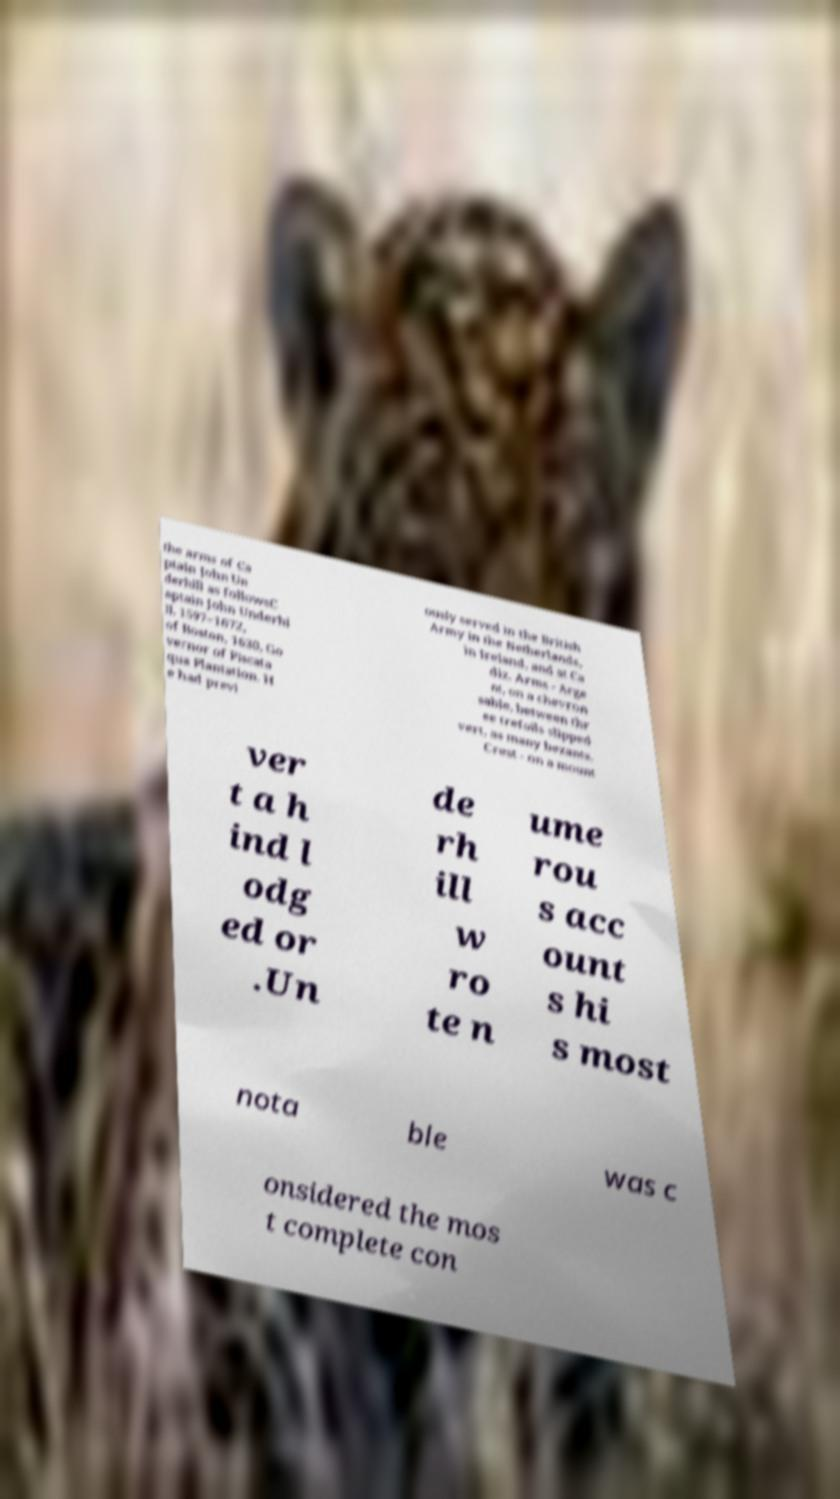I need the written content from this picture converted into text. Can you do that? the arms of Ca ptain John Un derhill as followsC aptain John Underhi ll, 1597–1672, of Boston, 1630, Go vernor of Piscata qua Plantation. H e had previ ously served in the British Army in the Netherlands, in Ireland, and at Ca diz. Arms - Arge nt, on a chevron sable, between thr ee trefoils slipped vert, as many bezants. Crest - on a mount ver t a h ind l odg ed or .Un de rh ill w ro te n ume rou s acc ount s hi s most nota ble was c onsidered the mos t complete con 